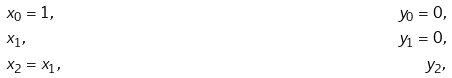<formula> <loc_0><loc_0><loc_500><loc_500>& x _ { 0 } = 1 , & y _ { 0 } = 0 , \\ & x _ { 1 } , & y _ { 1 } = 0 , \\ & x _ { 2 } = x _ { 1 } , & y _ { 2 } , \\</formula> 